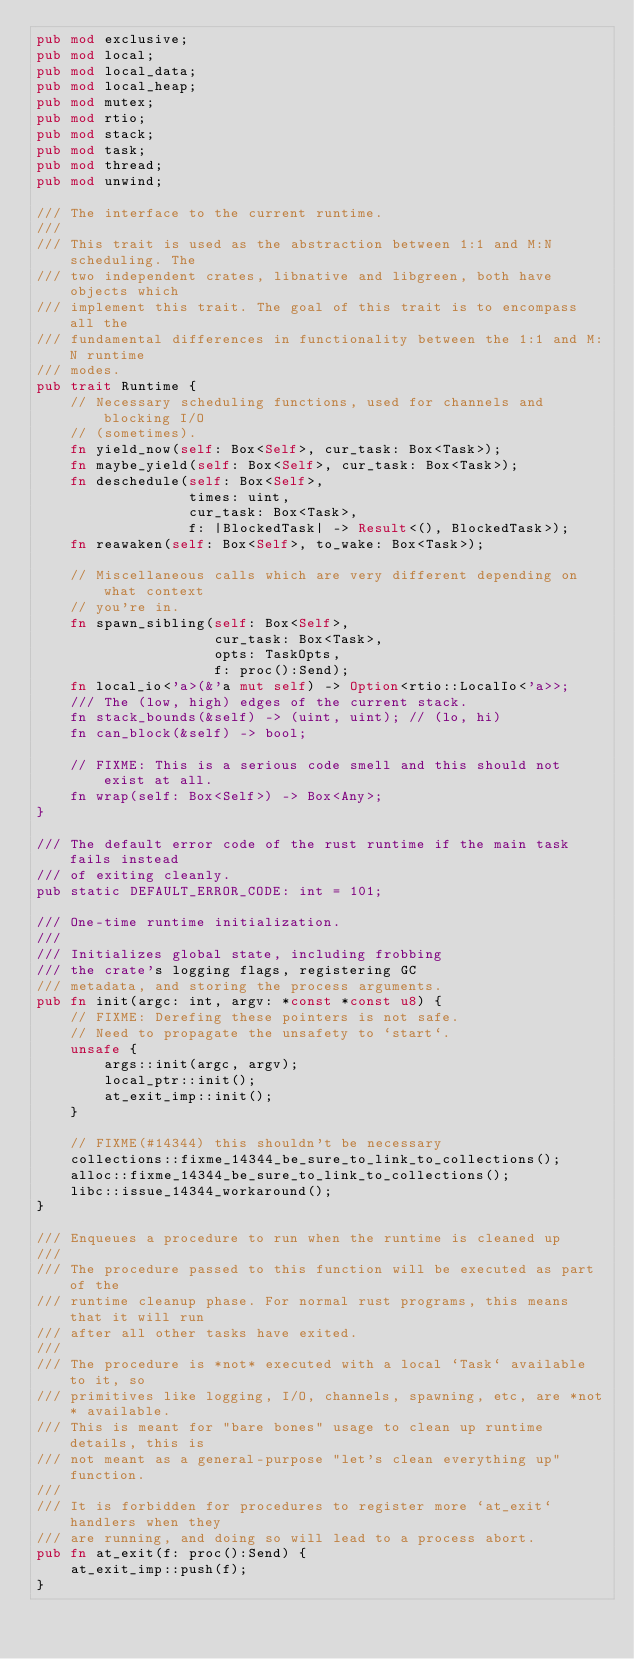<code> <loc_0><loc_0><loc_500><loc_500><_Rust_>pub mod exclusive;
pub mod local;
pub mod local_data;
pub mod local_heap;
pub mod mutex;
pub mod rtio;
pub mod stack;
pub mod task;
pub mod thread;
pub mod unwind;

/// The interface to the current runtime.
///
/// This trait is used as the abstraction between 1:1 and M:N scheduling. The
/// two independent crates, libnative and libgreen, both have objects which
/// implement this trait. The goal of this trait is to encompass all the
/// fundamental differences in functionality between the 1:1 and M:N runtime
/// modes.
pub trait Runtime {
    // Necessary scheduling functions, used for channels and blocking I/O
    // (sometimes).
    fn yield_now(self: Box<Self>, cur_task: Box<Task>);
    fn maybe_yield(self: Box<Self>, cur_task: Box<Task>);
    fn deschedule(self: Box<Self>,
                  times: uint,
                  cur_task: Box<Task>,
                  f: |BlockedTask| -> Result<(), BlockedTask>);
    fn reawaken(self: Box<Self>, to_wake: Box<Task>);

    // Miscellaneous calls which are very different depending on what context
    // you're in.
    fn spawn_sibling(self: Box<Self>,
                     cur_task: Box<Task>,
                     opts: TaskOpts,
                     f: proc():Send);
    fn local_io<'a>(&'a mut self) -> Option<rtio::LocalIo<'a>>;
    /// The (low, high) edges of the current stack.
    fn stack_bounds(&self) -> (uint, uint); // (lo, hi)
    fn can_block(&self) -> bool;

    // FIXME: This is a serious code smell and this should not exist at all.
    fn wrap(self: Box<Self>) -> Box<Any>;
}

/// The default error code of the rust runtime if the main task fails instead
/// of exiting cleanly.
pub static DEFAULT_ERROR_CODE: int = 101;

/// One-time runtime initialization.
///
/// Initializes global state, including frobbing
/// the crate's logging flags, registering GC
/// metadata, and storing the process arguments.
pub fn init(argc: int, argv: *const *const u8) {
    // FIXME: Derefing these pointers is not safe.
    // Need to propagate the unsafety to `start`.
    unsafe {
        args::init(argc, argv);
        local_ptr::init();
        at_exit_imp::init();
    }

    // FIXME(#14344) this shouldn't be necessary
    collections::fixme_14344_be_sure_to_link_to_collections();
    alloc::fixme_14344_be_sure_to_link_to_collections();
    libc::issue_14344_workaround();
}

/// Enqueues a procedure to run when the runtime is cleaned up
///
/// The procedure passed to this function will be executed as part of the
/// runtime cleanup phase. For normal rust programs, this means that it will run
/// after all other tasks have exited.
///
/// The procedure is *not* executed with a local `Task` available to it, so
/// primitives like logging, I/O, channels, spawning, etc, are *not* available.
/// This is meant for "bare bones" usage to clean up runtime details, this is
/// not meant as a general-purpose "let's clean everything up" function.
///
/// It is forbidden for procedures to register more `at_exit` handlers when they
/// are running, and doing so will lead to a process abort.
pub fn at_exit(f: proc():Send) {
    at_exit_imp::push(f);
}
</code> 